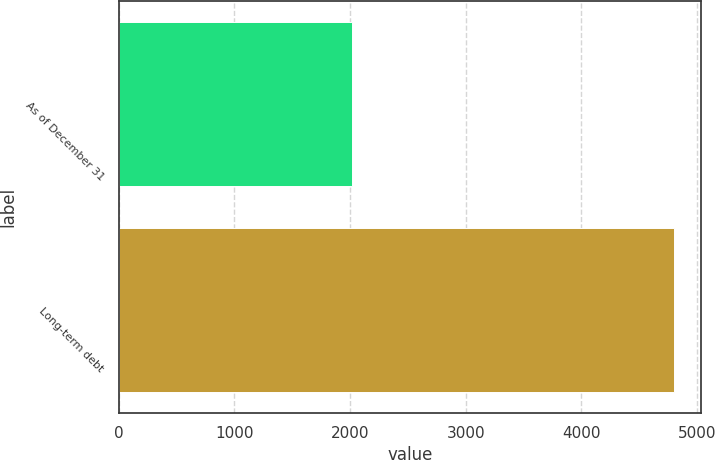Convert chart to OTSL. <chart><loc_0><loc_0><loc_500><loc_500><bar_chart><fcel>As of December 31<fcel>Long-term debt<nl><fcel>2014<fcel>4799<nl></chart> 